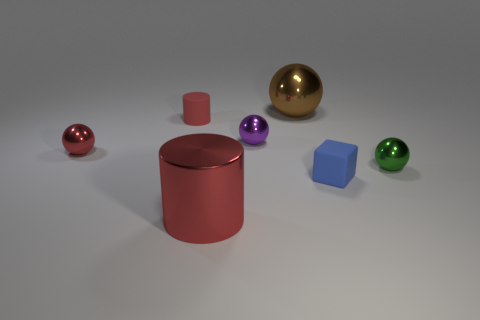Subtract all large balls. How many balls are left? 3 Add 3 tiny rubber spheres. How many objects exist? 10 Subtract all red balls. How many balls are left? 3 Subtract all cyan spheres. Subtract all brown cubes. How many spheres are left? 4 Subtract all balls. How many objects are left? 3 Add 4 big objects. How many big objects are left? 6 Add 5 big brown shiny balls. How many big brown shiny balls exist? 6 Subtract 0 red blocks. How many objects are left? 7 Subtract all tiny cyan matte spheres. Subtract all tiny metal objects. How many objects are left? 4 